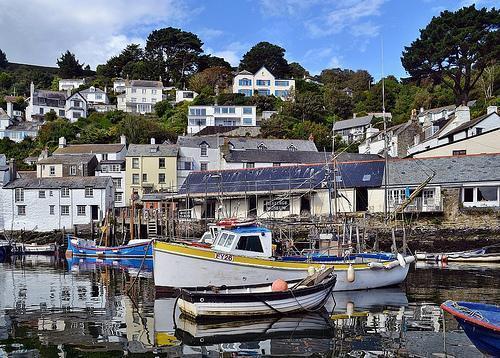How many blue boats are there?
Give a very brief answer. 2. 